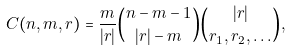<formula> <loc_0><loc_0><loc_500><loc_500>C ( n , m , r ) = \frac { m } { | r | } { n - m - 1 \choose | r | - m } { | r | \choose r _ { 1 } , r _ { 2 } , \dots } ,</formula> 